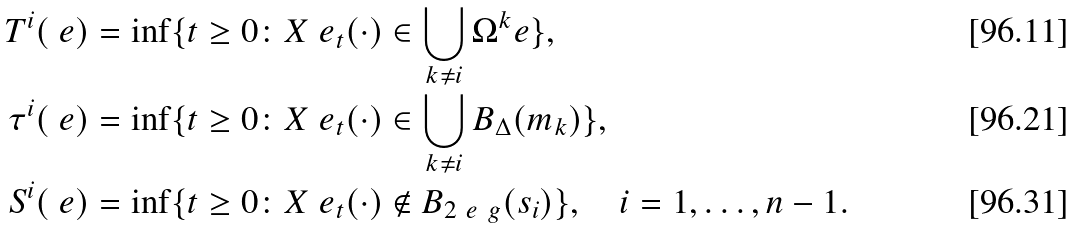<formula> <loc_0><loc_0><loc_500><loc_500>T ^ { i } ( \ e ) & = \inf \{ t \geq 0 \colon X ^ { \ } e _ { t } ( \cdot ) \in \bigcup _ { k \neq i } \Omega ^ { k } _ { \ } e \} , \\ \tau ^ { i } ( \ e ) & = \inf \{ t \geq 0 \colon X ^ { \ } e _ { t } ( \cdot ) \in \bigcup _ { k \neq i } B _ { \Delta } ( m _ { k } ) \} , \\ S ^ { i } ( \ e ) & = \inf \{ t \geq 0 \colon X ^ { \ } e _ { t } ( \cdot ) \notin B _ { 2 \ e ^ { \ } g } ( s _ { i } ) \} , \quad i = 1 , \dots , n - 1 .</formula> 